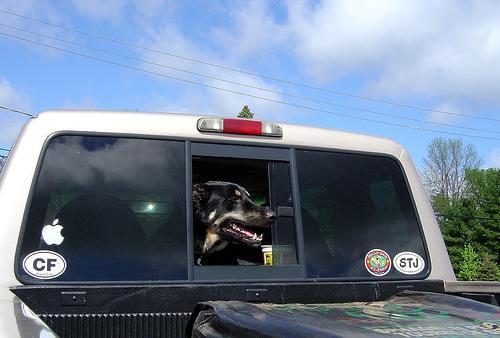How many trucks can be seen?
Give a very brief answer. 1. How many elephants are there?
Give a very brief answer. 0. 